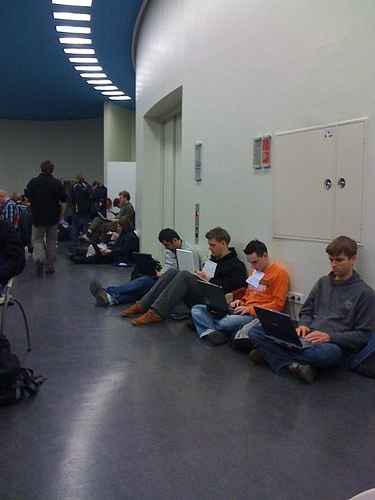Describe the objects in this image and their specific colors. I can see people in darkblue, black, gray, and maroon tones, people in darkblue, black, maroon, gray, and darkgray tones, people in darkblue, black, brown, and gray tones, people in darkblue, black, and gray tones, and people in darkblue, black, gray, navy, and darkgray tones in this image. 